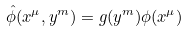<formula> <loc_0><loc_0><loc_500><loc_500>\hat { \phi } ( x ^ { \mu } , y ^ { m } ) = g ( y ^ { m } ) \phi ( x ^ { \mu } )</formula> 